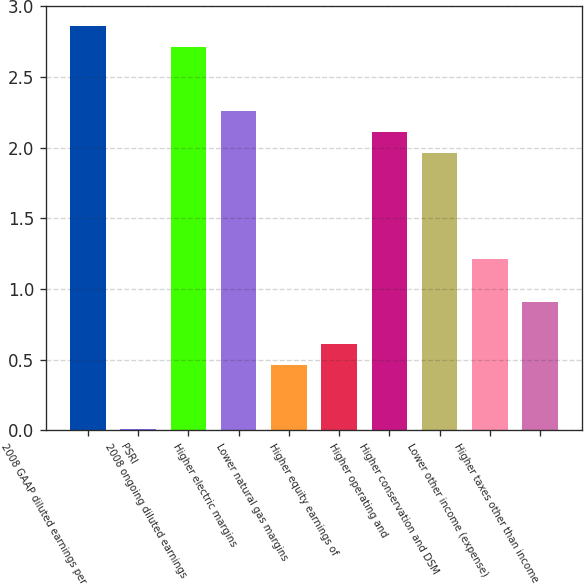<chart> <loc_0><loc_0><loc_500><loc_500><bar_chart><fcel>2008 GAAP diluted earnings per<fcel>PSRI<fcel>2008 ongoing diluted earnings<fcel>Higher electric margins<fcel>Lower natural gas margins<fcel>Higher equity earnings of<fcel>Higher operating and<fcel>Higher conservation and DSM<fcel>Lower other income (expense)<fcel>Higher taxes other than income<nl><fcel>2.86<fcel>0.01<fcel>2.71<fcel>2.26<fcel>0.46<fcel>0.61<fcel>2.11<fcel>1.96<fcel>1.21<fcel>0.91<nl></chart> 